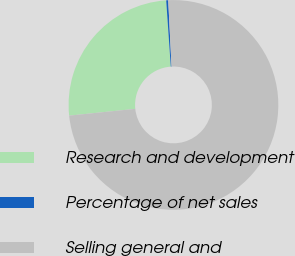<chart> <loc_0><loc_0><loc_500><loc_500><pie_chart><fcel>Research and development<fcel>Percentage of net sales<fcel>Selling general and<nl><fcel>25.52%<fcel>0.31%<fcel>74.16%<nl></chart> 